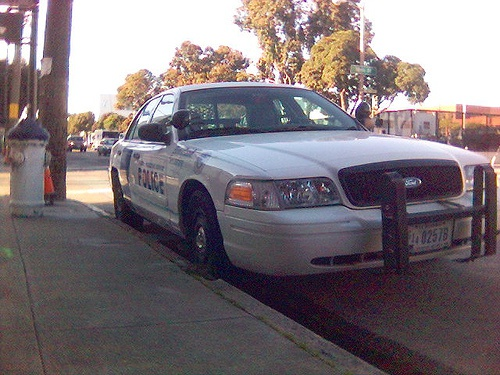Describe the objects in this image and their specific colors. I can see car in gray, black, and darkgray tones, fire hydrant in gray tones, traffic light in gray, brown, lightpink, and purple tones, truck in gray, purple, and ivory tones, and car in gray, darkgray, and purple tones in this image. 